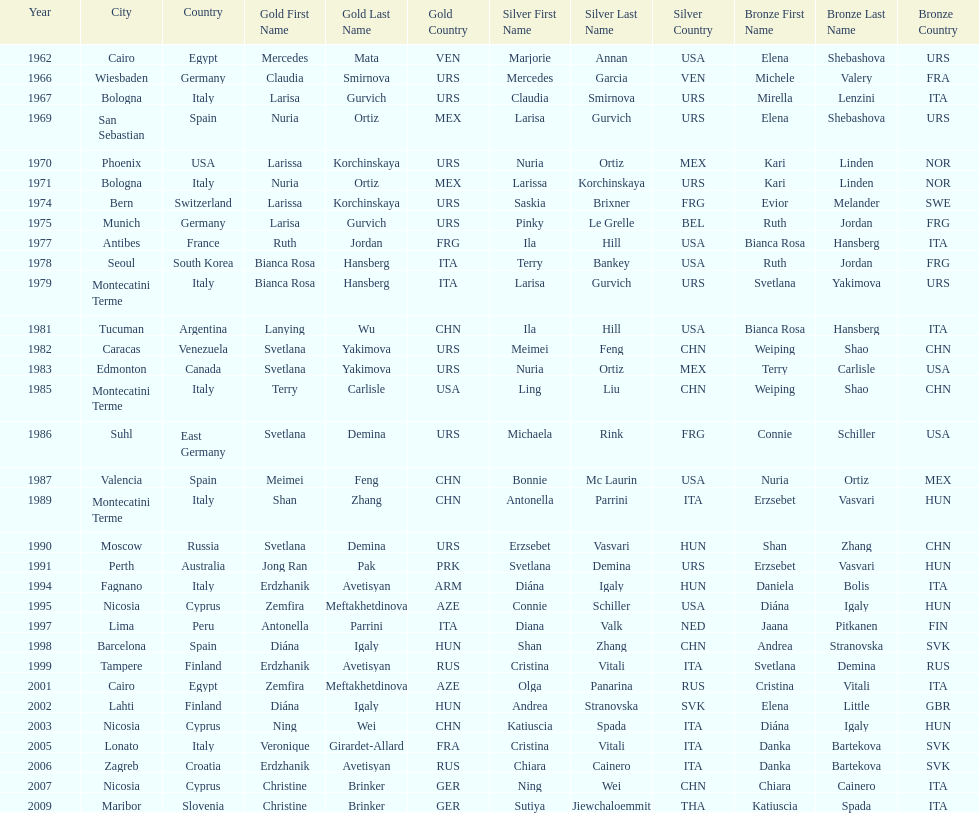What is the total amount of winnings for the united states in gold, silver and bronze? 9. 